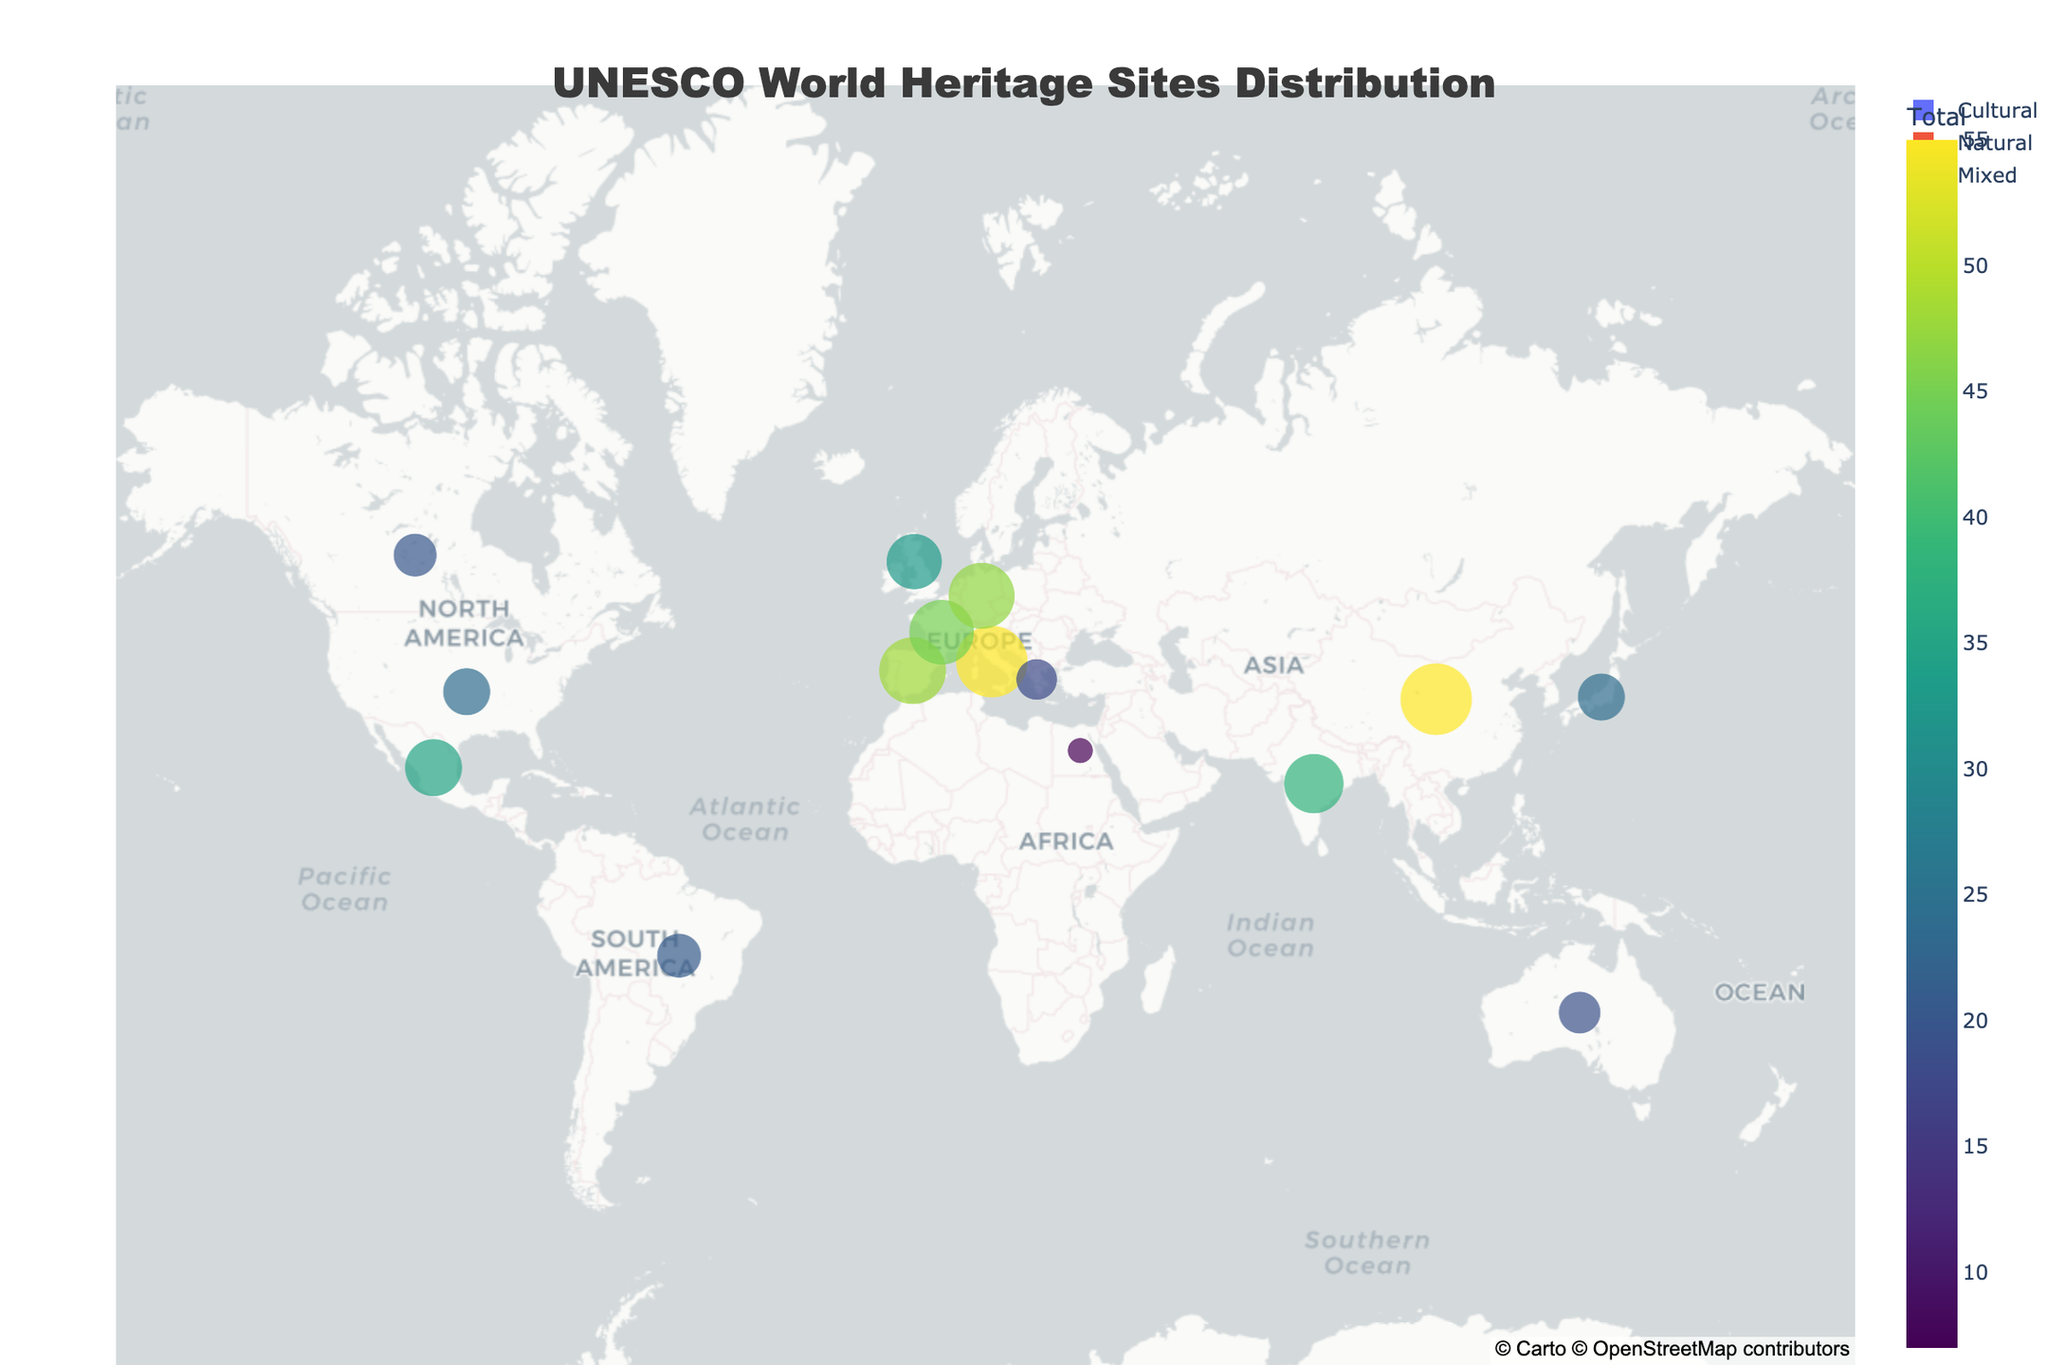Which country has the highest total number of UNESCO World Heritage Sites? To find the country with the highest number of sites, check the size of the markers on the map and the number annotations. Italy has the largest marker with a total of 55 sites labeled on the map.
Answer: Italy How many UNESCO World Heritage Sites are there in China? Locate China on the map, then refer to the label. China has 55 world heritage sites.
Answer: 55 Which country has more Natural World Heritage Sites, the United States or Australia? Compare the Natural column values for both countries from the provided data. The United States has 12 Natural sites, while Australia also has 12. This means both countries have the same number of Natural World Heritage Sites.
Answer: United States and Australia have the same number of Natural Sites What is the combined total of Cultural and Mixed World Heritage Sites in India? Add the values for Cultural and Mixed sites for India. Cultural is 30, and Mixed is 1. So, the total is 30 + 1 = 31.
Answer: 31 Which type of UNESCO World Heritage Sites is most common overall? Refer to the pie chart inset. The 'Cultural' label occupies the largest portion of the pie chart, indicating it is the most common type of site.
Answer: Cultural What is the average number of World Heritage Sites (Total) across all the listed countries? Sum the total numbers of sites for each country, then divide by the number of countries, which is 15. The sum is 46+55+48+45+45+38+35+33+24+21+19+24+18+20+7 = 478, and the average is 478/15 = 31.87.
Answer: 31.87 How many countries have at least 10 World Heritage Sites? Count the number of countries where the Total number of sites is 10 or more. In the data, all countries except Egypt have 10 or more sites. So, the count is 14.
Answer: 14 Which country has the smallest total number of World Heritage Sites and how many does it have? Locate the country with the smallest marker on the map and check the number annotation. Egypt has the smallest total with 7 World Heritage Sites.
Answer: Egypt, 7 How does the total number of Natural World Heritage Sites in Brazil compare to that of Canada? Look at the values for the Natural sites column. Brazil has 7 Natural sites, whereas Canada has 10. Canada has 3 more Natural World Heritage Sites than Brazil.
Answer: Canada has 3 more sites Which country has more Mixed World Heritage Sites, Spain or Australia? Compare the Mixed column values for both countries. Spain has 2 Mixed sites, while Australia has 4. Thus, Australia has more Mixed World Heritage Sites than Spain.
Answer: Australia 